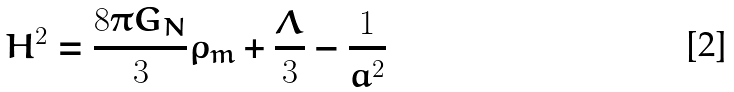<formula> <loc_0><loc_0><loc_500><loc_500>H ^ { 2 } = \frac { 8 \pi G _ { N } } { 3 } \rho _ { m } + \frac { \Lambda } { 3 } - \frac { 1 } { a ^ { 2 } }</formula> 